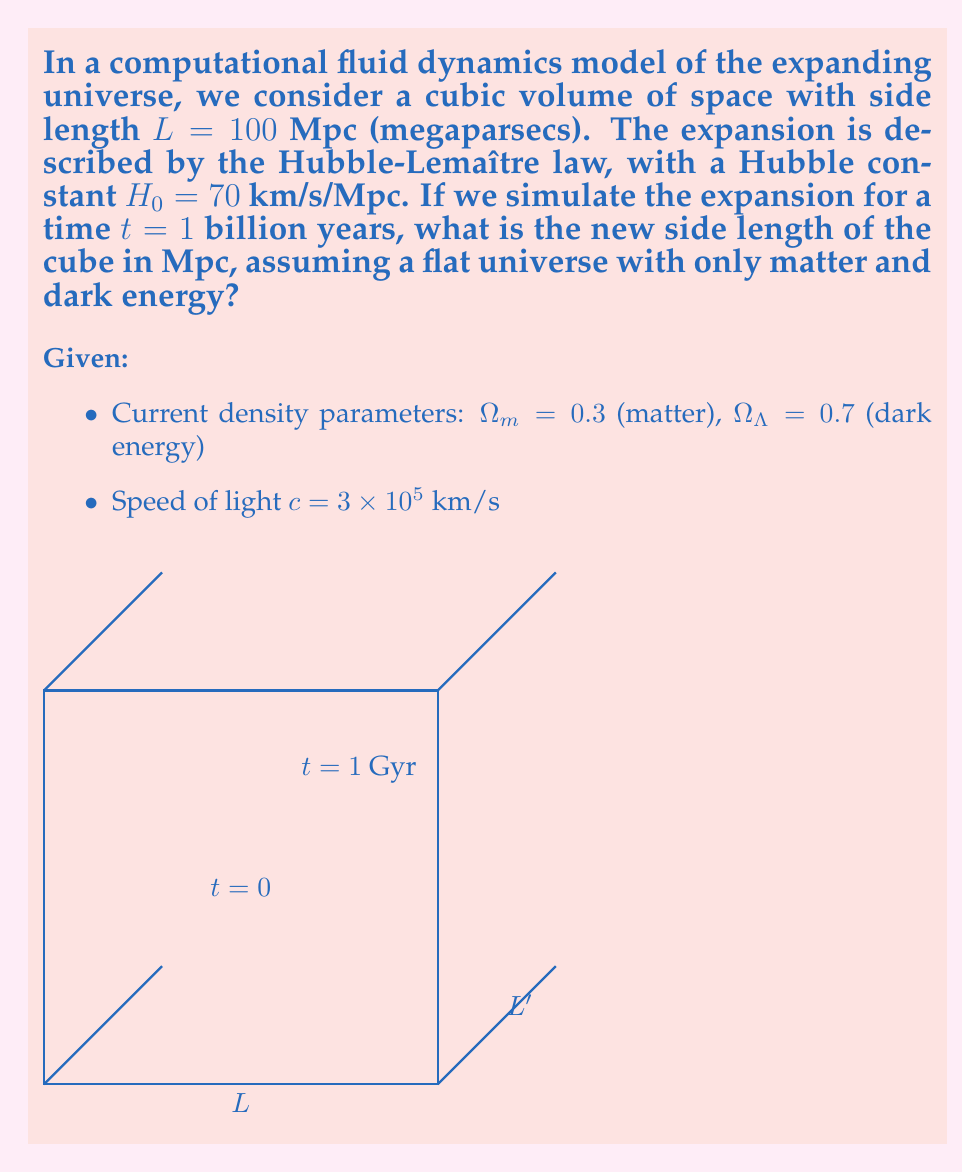Provide a solution to this math problem. To solve this problem, we need to use the Friedmann equation for a flat universe with matter and dark energy:

$$\left(\frac{\dot{a}}{a}\right)^2 = H_0^2 [\Omega_m a^{-3} + \Omega_\Lambda]$$

Where $a$ is the scale factor of the universe, and $\dot{a}$ is its time derivative.

Steps:
1) First, we need to convert the time to seconds:
   $t = 1 \text{ Gyr} = 1 \times 10^9 \text{ years} = 3.1536 \times 10^{16} \text{ s}$

2) We can solve for $a(t)$ numerically using the Friedmann equation. However, for small time intervals relative to the age of the universe, we can approximate the expansion using the current Hubble constant:

   $\frac{\Delta L}{L} \approx H_0 t$

3) Calculate the relative expansion:
   $\frac{\Delta L}{L} = (70 \text{ km/s/Mpc}) \times (3.1536 \times 10^{16} \text{ s}) \times (3.24 \times 10^{-20} \text{ Mpc/km})$
   $\frac{\Delta L}{L} = 0.0716$

4) The new side length $L'$ is:
   $L' = L + \Delta L = L(1 + 0.0716) = 100 \text{ Mpc} \times 1.0716$
   $L' = 107.16 \text{ Mpc}$

Note: This linear approximation slightly underestimates the expansion compared to a full numerical solution of the Friedmann equation, but it's a good approximation for the given timescale.
Answer: 107.16 Mpc 